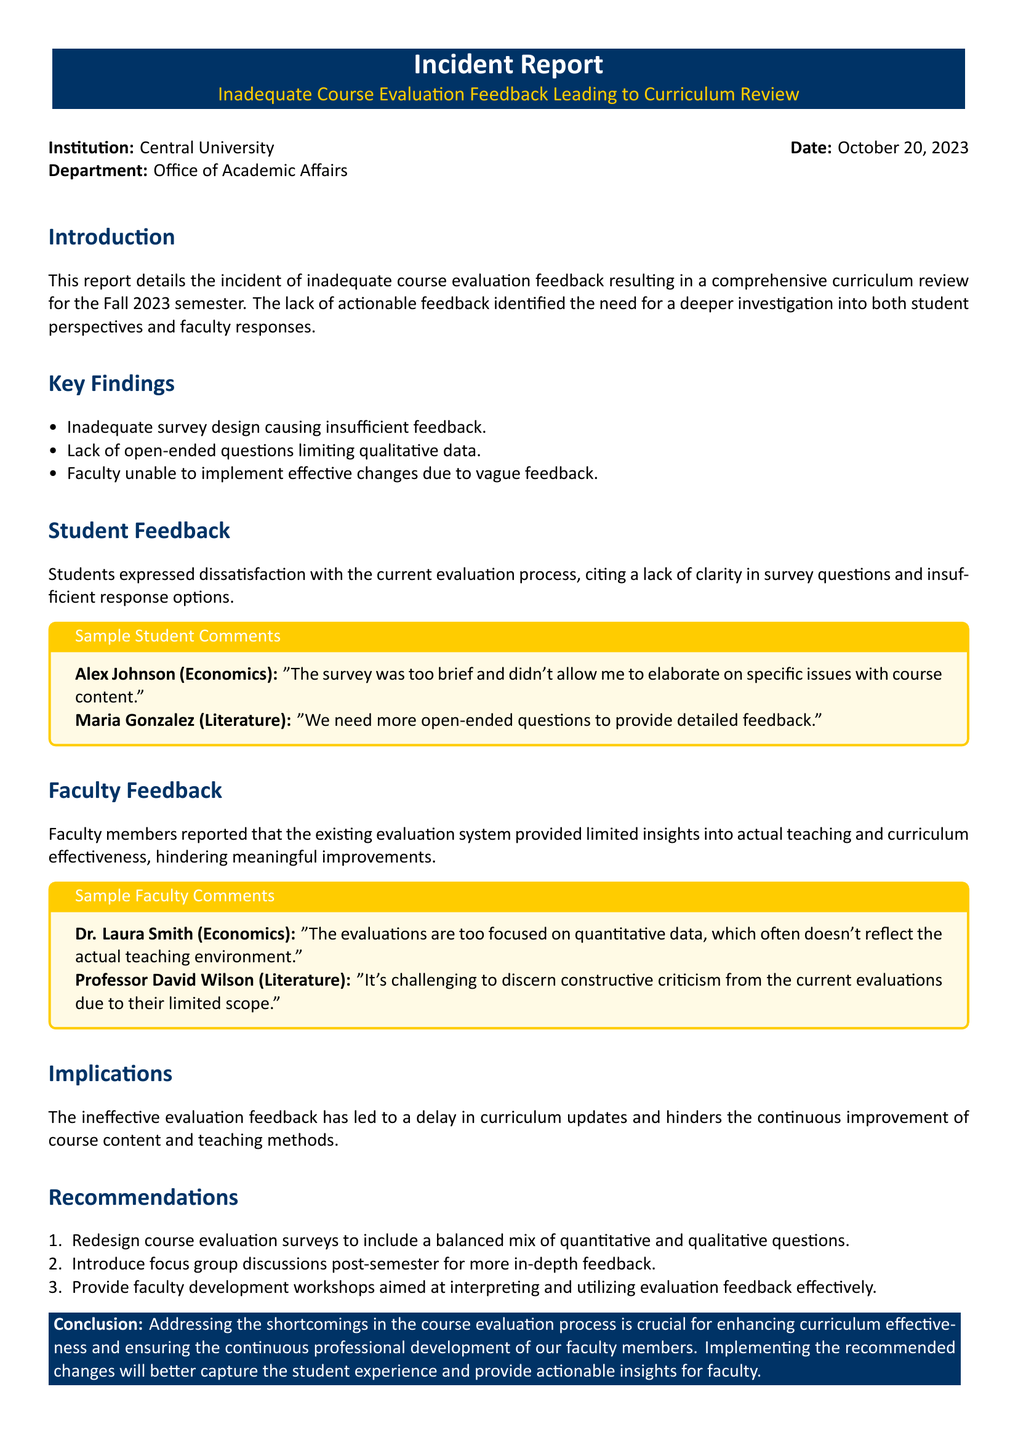what is the title of the incident report? The title of the incident report is presented prominently at the top and is "Inadequate Course Evaluation Feedback Leading to Curriculum Review."
Answer: Inadequate Course Evaluation Feedback Leading to Curriculum Review who authored the incident report? The incident report indicates that it was released by the Office of Academic Affairs at Central University.
Answer: Office of Academic Affairs what date was the report issued? The report specifies the date it was issued as October 20, 2023.
Answer: October 20, 2023 which department is primarily involved in this report? The department involved is listed at the beginning of the report, under the Institution and Date section.
Answer: Office of Academic Affairs how many student comments are provided in the report? The report includes two sample student comments to illustrate the feedback received.
Answer: 2 what are the key findings regarding survey design? The report mentions that the survey design is inadequate, causing insufficient feedback.
Answer: Inadequate survey design causing insufficient feedback what recommendation involves faculty development? The report recommends providing faculty development workshops aimed at interpreting and utilizing evaluation feedback effectively.
Answer: Provide faculty development workshops what qualitative feedback aspect was lacking according to students? Students indicated that a lack of open-ended questions limited their ability to provide qualitative data in the evaluations.
Answer: Lack of open-ended questions what was one implication of the ineffective evaluation feedback? The report states that the ineffective evaluation feedback has led to a delay in curriculum updates.
Answer: Delay in curriculum updates who expressed concerns about the focus of evaluations in their feedback? Dr. Laura Smith from the Economics department expressed concerns in her feedback about the focus on quantitative data.
Answer: Dr. Laura Smith 